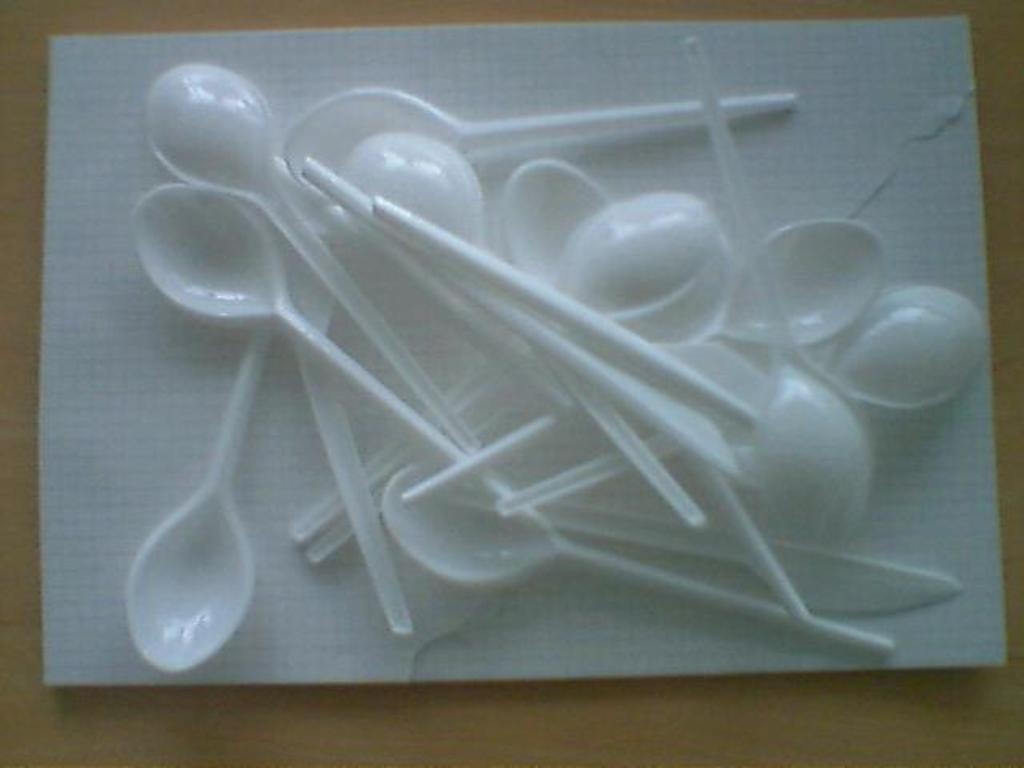What is the main object in the center of the image? There is a tissue paper in the center of the image. What is placed on the tissue paper? There are spoons on the tissue paper. What can be seen in the background of the image? There is a table in the background of the image. What type of mint is growing on the table in the image? There is no mint plant or any other vegetation present on the table in the image. 